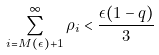<formula> <loc_0><loc_0><loc_500><loc_500>\sum _ { i = M ( \epsilon ) + 1 } ^ { \infty } \rho _ { i } < \frac { \epsilon ( 1 - q ) } { 3 }</formula> 